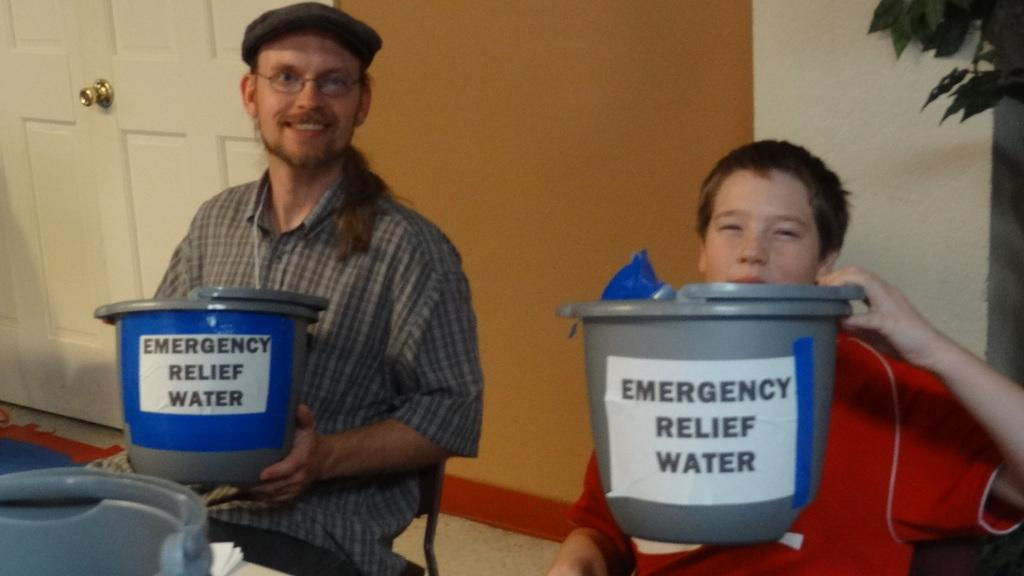Provide a one-sentence caption for the provided image. 2 people are holding up buckets that say emergency relief water on them. 